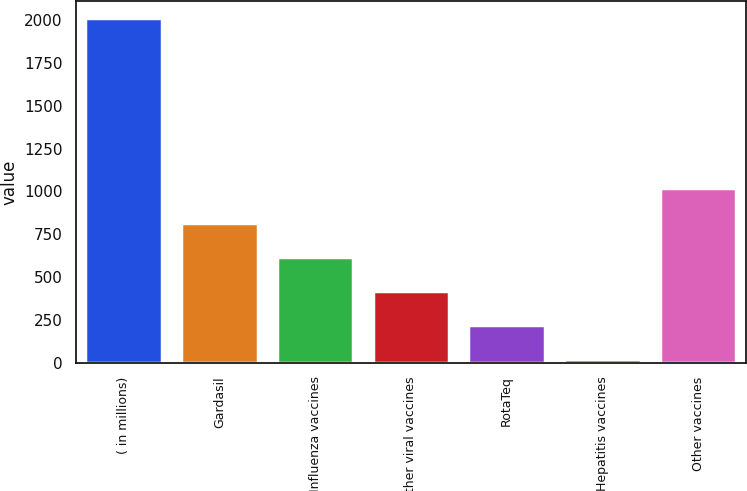<chart> <loc_0><loc_0><loc_500><loc_500><bar_chart><fcel>( in millions)<fcel>Gardasil<fcel>Influenza vaccines<fcel>Other viral vaccines<fcel>RotaTeq<fcel>Hepatitis vaccines<fcel>Other vaccines<nl><fcel>2010<fcel>819<fcel>620.5<fcel>422<fcel>223.5<fcel>25<fcel>1017.5<nl></chart> 